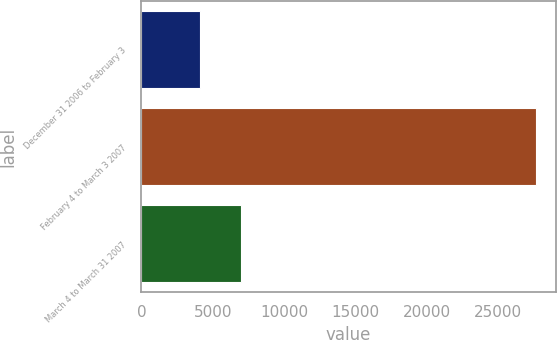<chart> <loc_0><loc_0><loc_500><loc_500><bar_chart><fcel>December 31 2006 to February 3<fcel>February 4 to March 3 2007<fcel>March 4 to March 31 2007<nl><fcel>4109<fcel>27647<fcel>6950<nl></chart> 